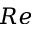<formula> <loc_0><loc_0><loc_500><loc_500>R e</formula> 